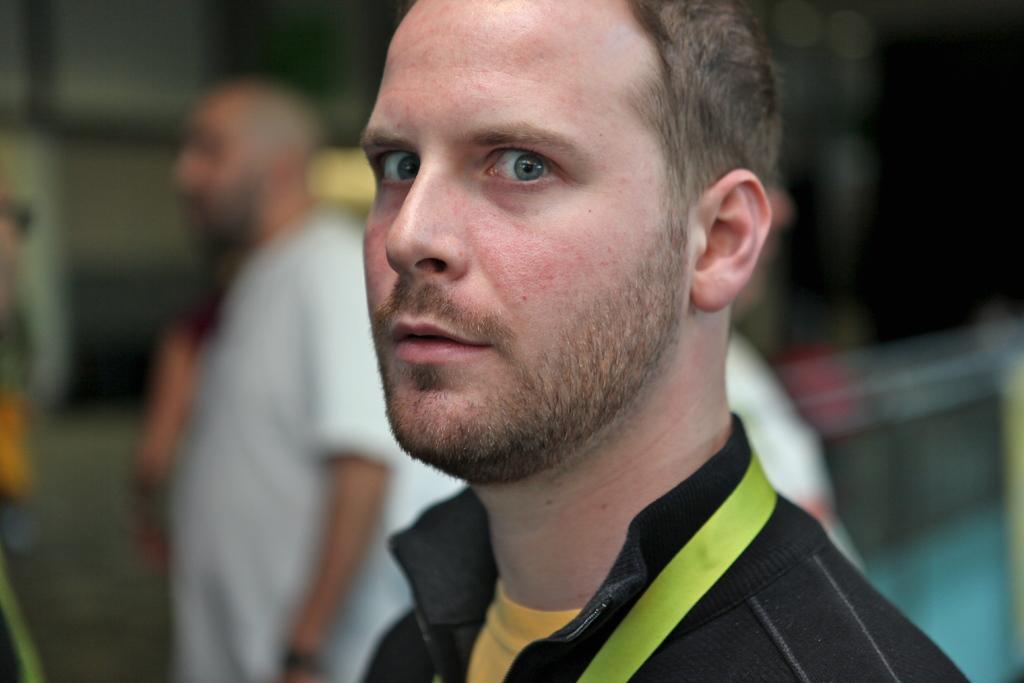Can you describe this image briefly? In the foreground we can see a person, he is wearing a black jacket. In the background there are people. The background is blurred. 